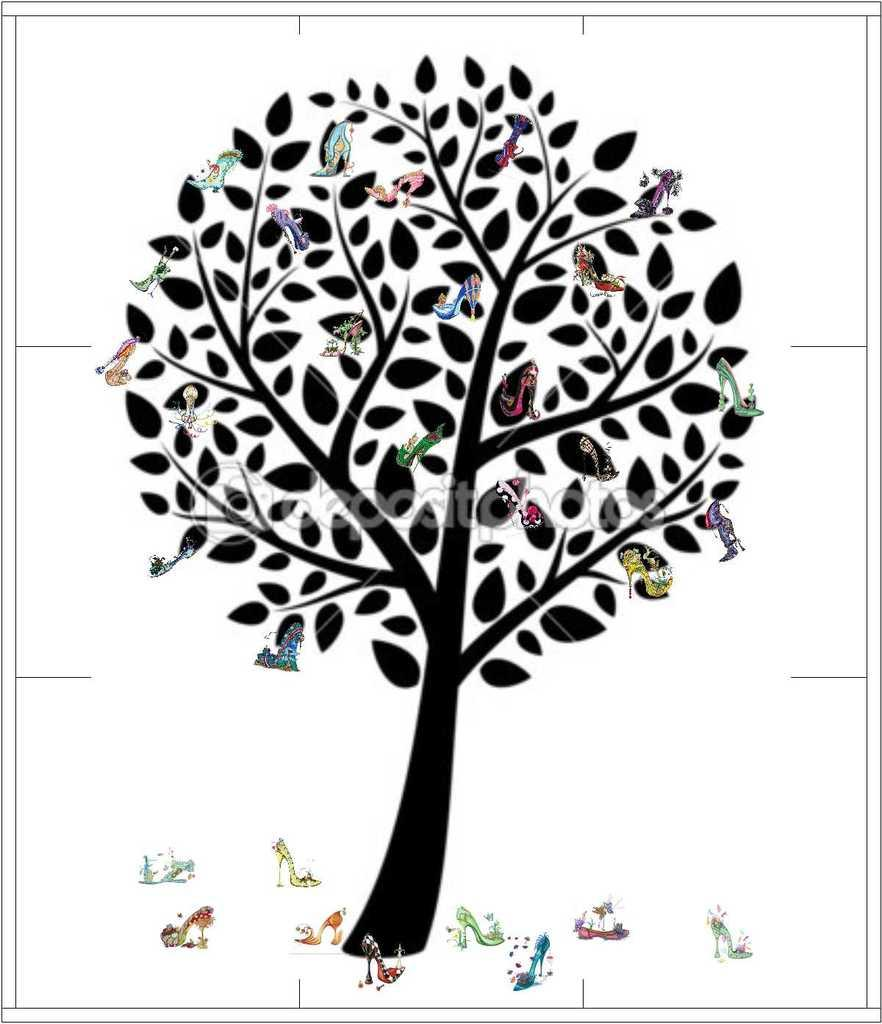What is depicted in the painting in the image? There is a painting of a tree in the image. What type of footwear can be seen in the image? There are sandals present in the image. What type of flesh can be seen in the image? There is no flesh present in the image; it features a painting of a tree and sandals. What type of cast can be seen in the image? There is no cast present in the image. 